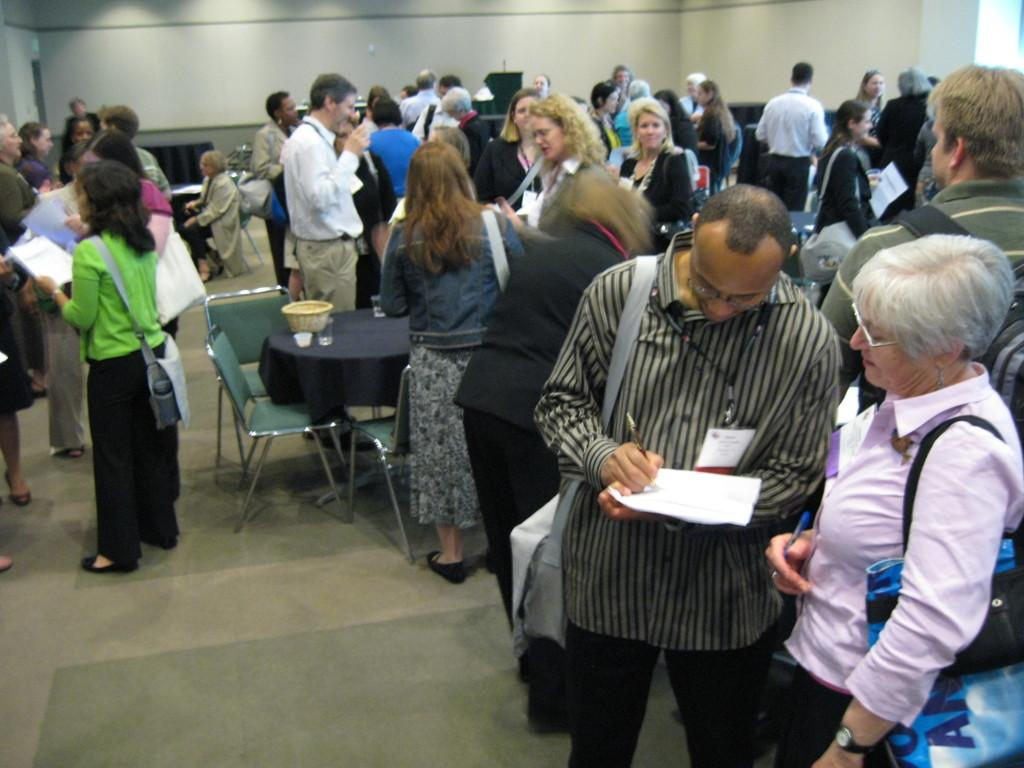Who is present in the image? There are people in the image. How are the people arranged in the image? The people are gathered in groups. Where are the groups located in the image? The groups are around tables. What are the people doing in the image? The people are talking to each other. What type of trousers is the deer wearing in the image? There is no deer present in the image, and therefore no trousers can be observed. 